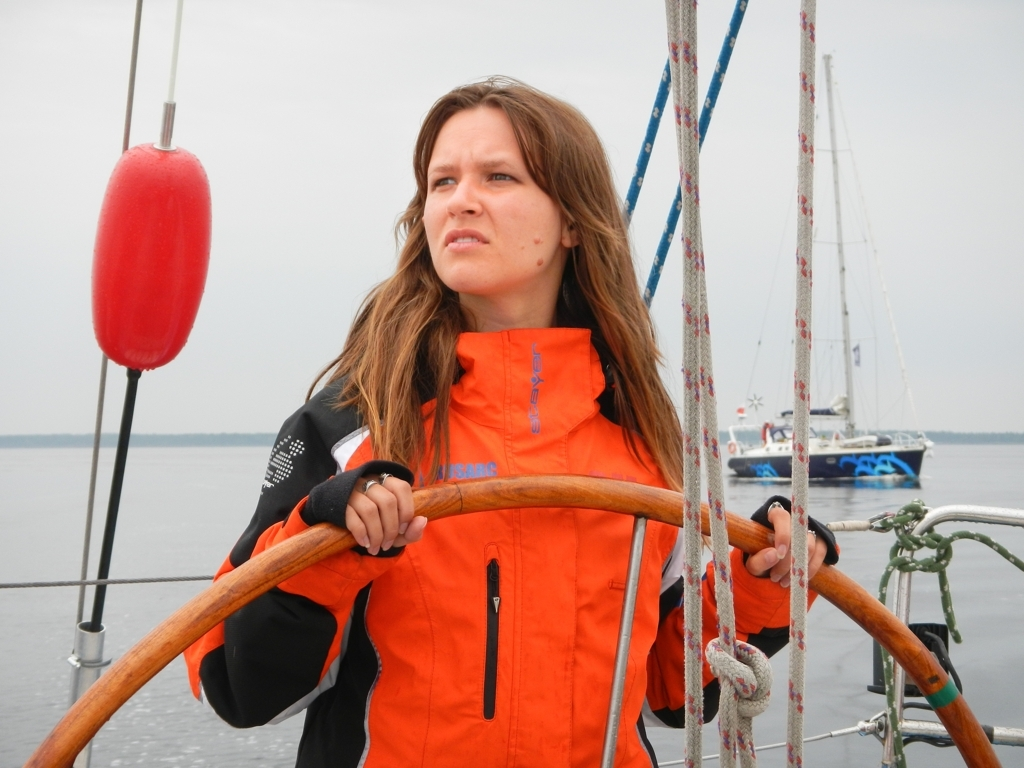Does the image have any color distortion? Upon analysis, the image appears to be free from any noticeable color distortions, exhibiting a clear and natural representation of the scene. The colors seem true to life, suggesting accurate white balance and color grading during the image's capture or post-processing. 